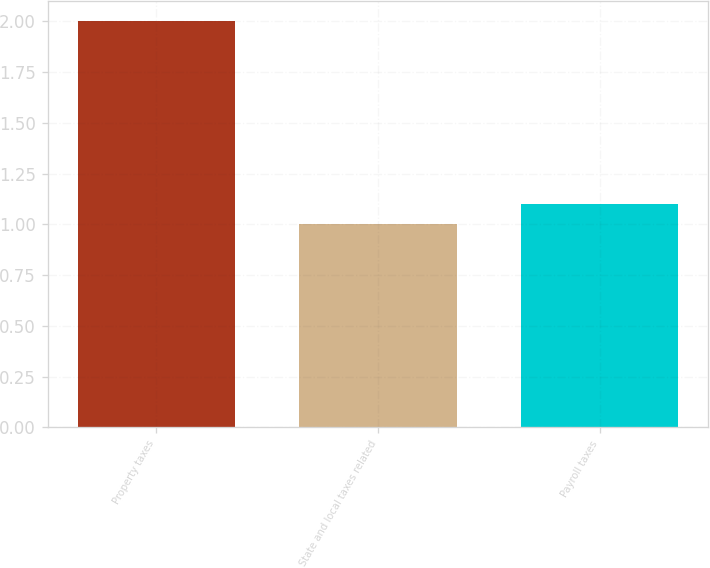Convert chart to OTSL. <chart><loc_0><loc_0><loc_500><loc_500><bar_chart><fcel>Property taxes<fcel>State and local taxes related<fcel>Payroll taxes<nl><fcel>2<fcel>1<fcel>1.1<nl></chart> 